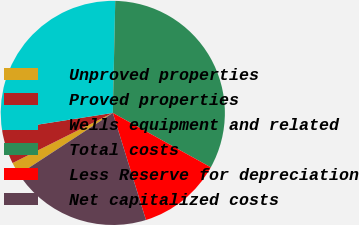Convert chart to OTSL. <chart><loc_0><loc_0><loc_500><loc_500><pie_chart><fcel>Unproved properties<fcel>Proved properties<fcel>Wells equipment and related<fcel>Total costs<fcel>Less Reserve for depreciation<fcel>Net capitalized costs<nl><fcel>1.84%<fcel>4.92%<fcel>27.81%<fcel>32.72%<fcel>12.16%<fcel>20.56%<nl></chart> 